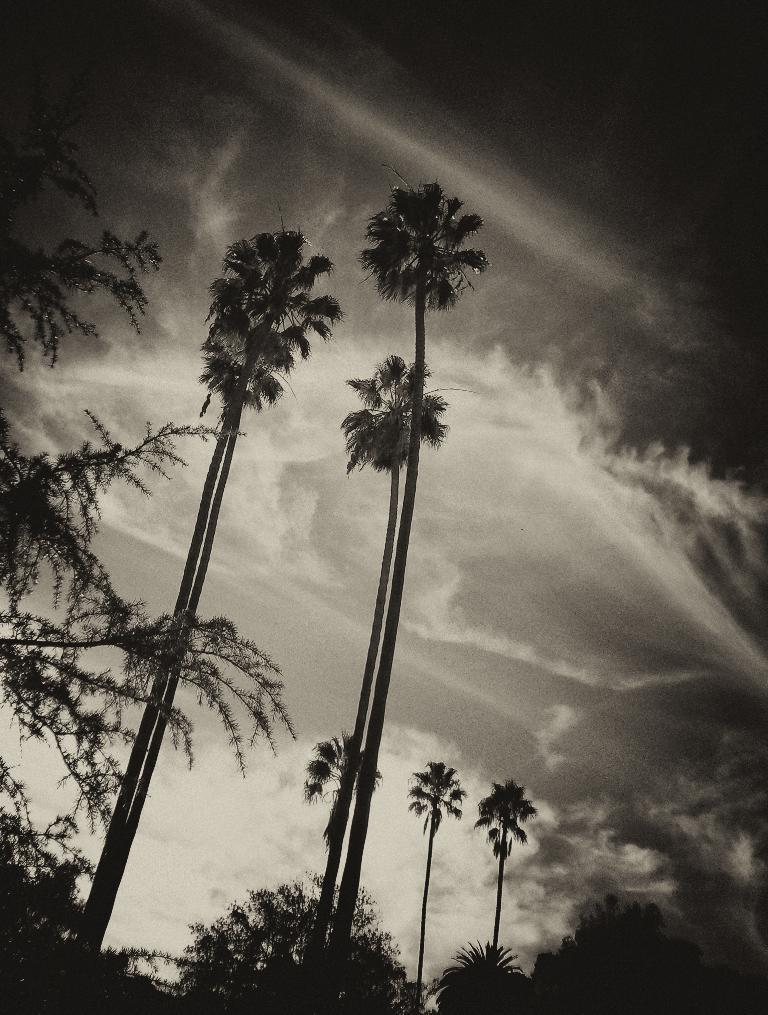What type of vegetation can be seen in the image? There are trees in the image. What part of the natural environment is visible in the image? The sky is visible in the background of the image. What is the color scheme of the image? The image is black and white in color. What type of mark does the ghost leave on the van in the image? There is no mention of a ghost or a van in the provided facts, and therefore, no such mark can be observed in the image. 